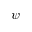<formula> <loc_0><loc_0><loc_500><loc_500>\psi</formula> 